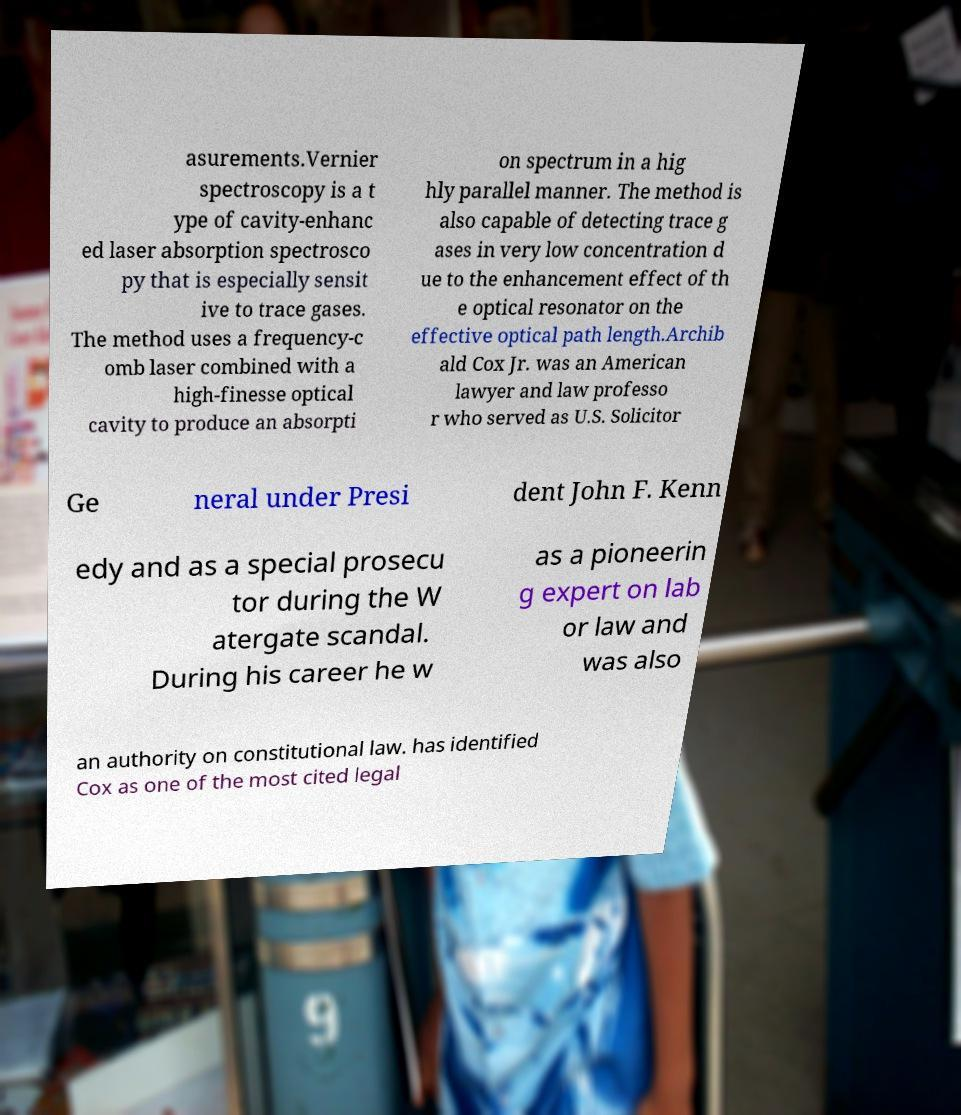Could you assist in decoding the text presented in this image and type it out clearly? asurements.Vernier spectroscopy is a t ype of cavity-enhanc ed laser absorption spectrosco py that is especially sensit ive to trace gases. The method uses a frequency-c omb laser combined with a high-finesse optical cavity to produce an absorpti on spectrum in a hig hly parallel manner. The method is also capable of detecting trace g ases in very low concentration d ue to the enhancement effect of th e optical resonator on the effective optical path length.Archib ald Cox Jr. was an American lawyer and law professo r who served as U.S. Solicitor Ge neral under Presi dent John F. Kenn edy and as a special prosecu tor during the W atergate scandal. During his career he w as a pioneerin g expert on lab or law and was also an authority on constitutional law. has identified Cox as one of the most cited legal 